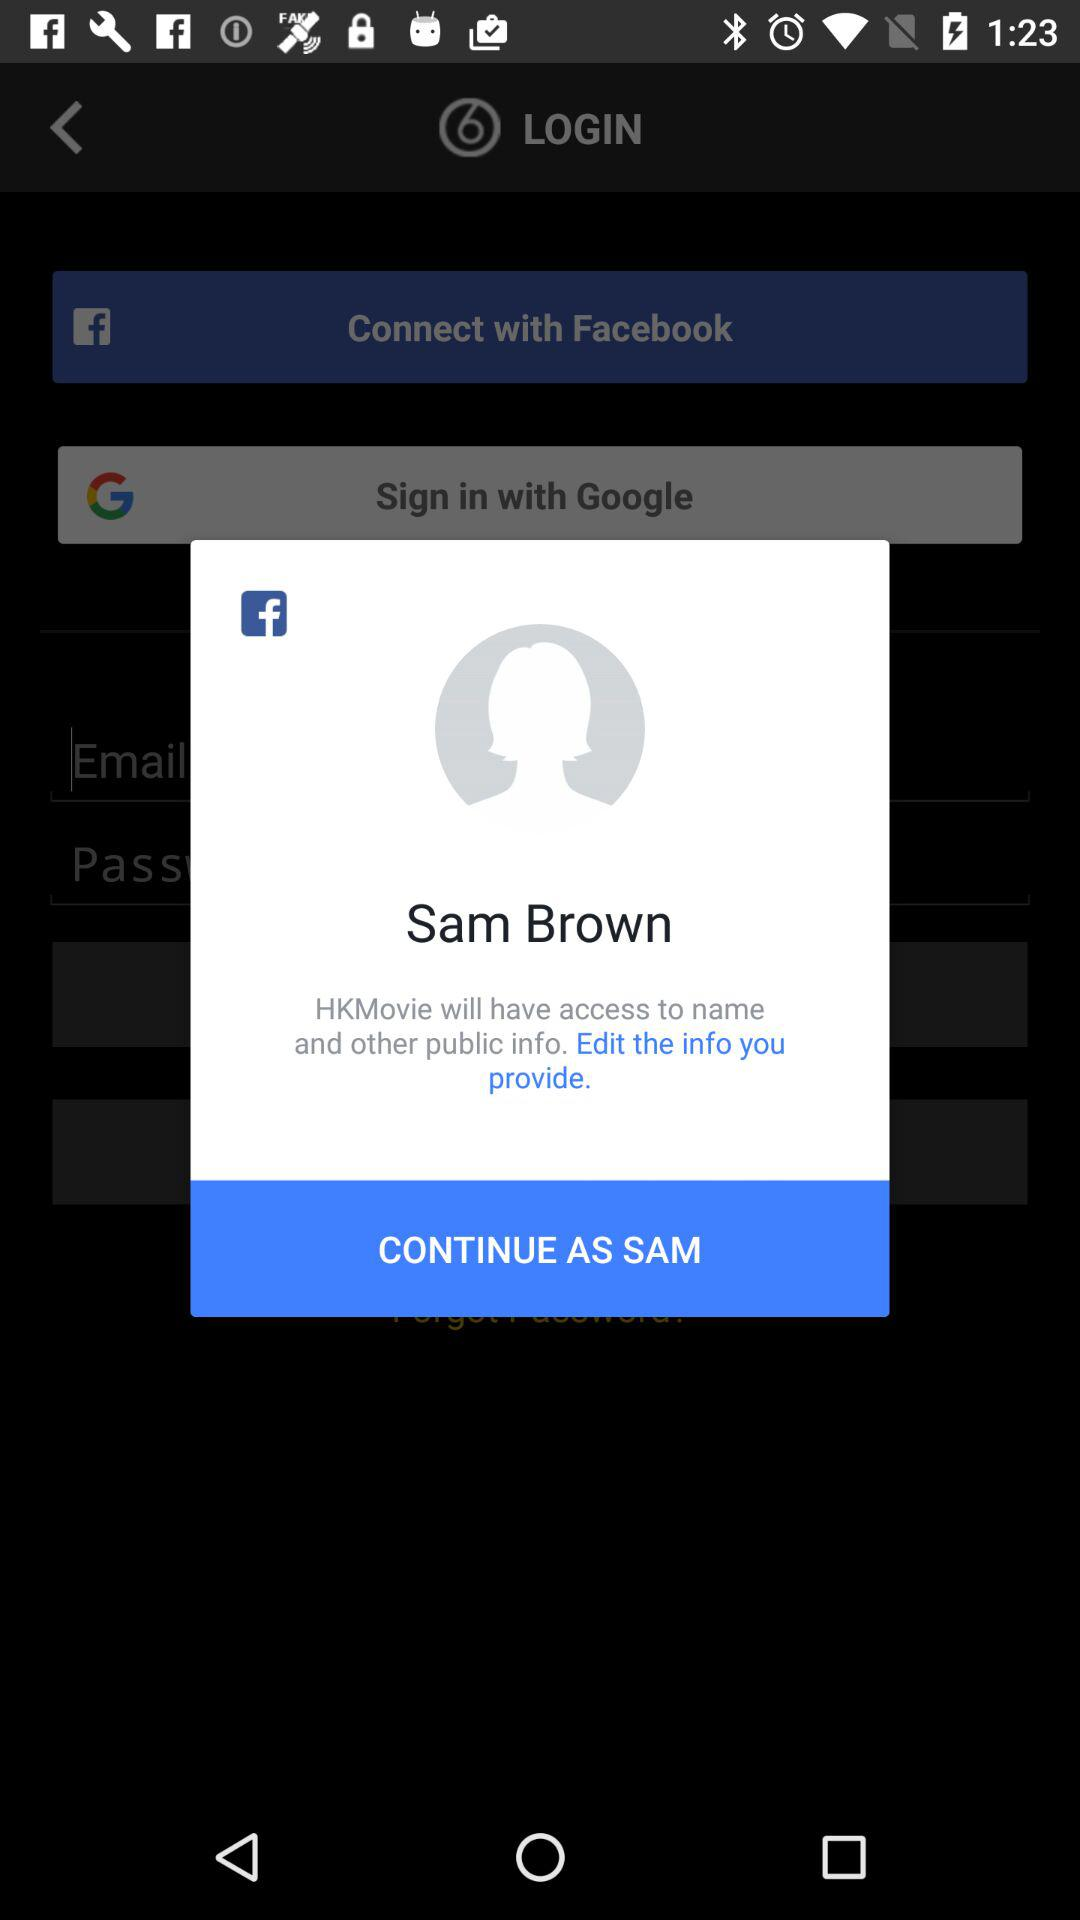What application is used to continue? The application that is used to continue is Facebook. 